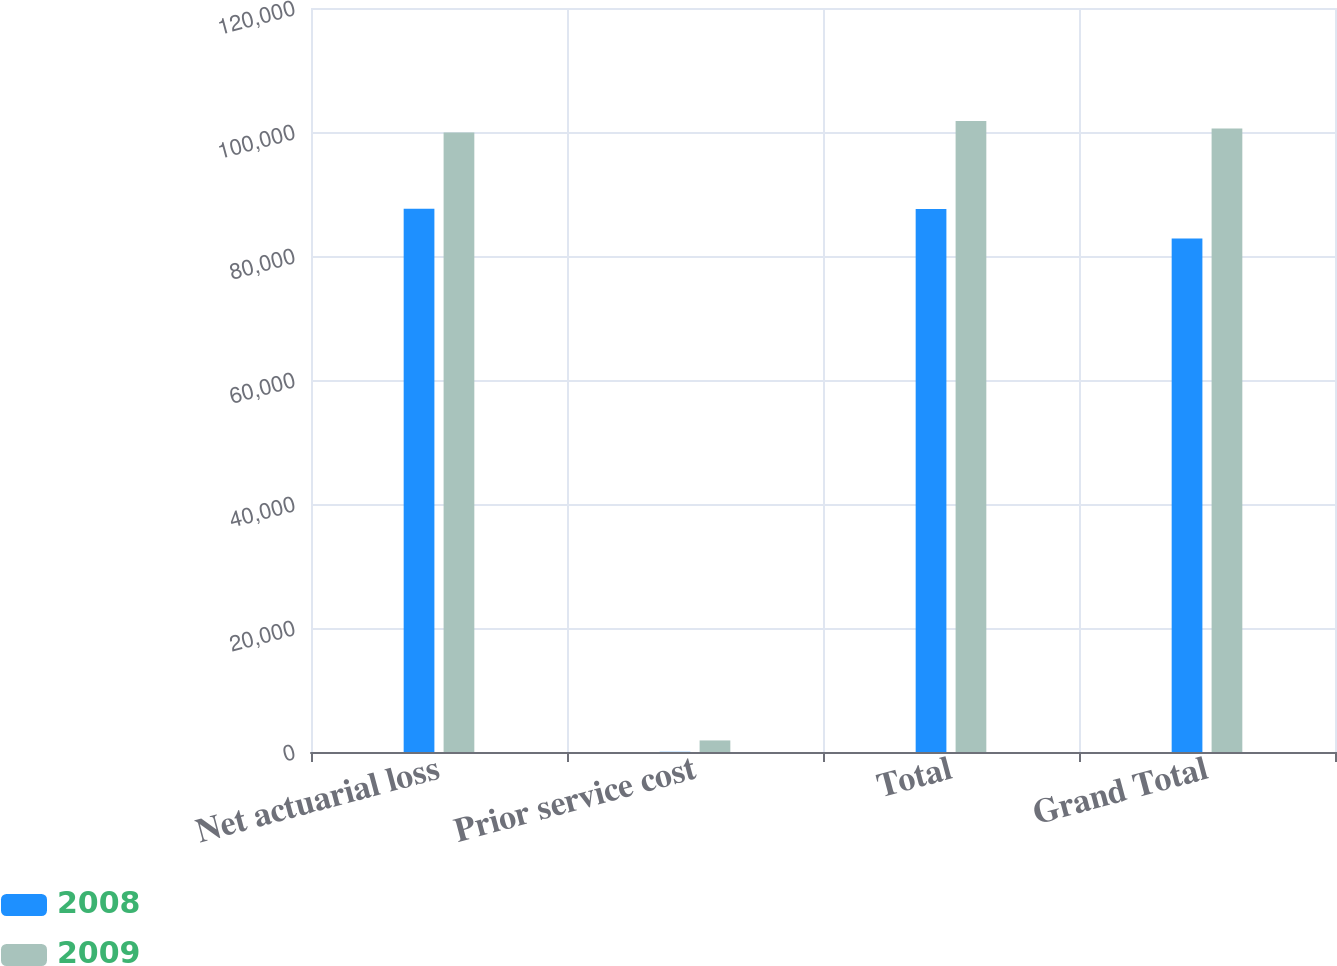Convert chart. <chart><loc_0><loc_0><loc_500><loc_500><stacked_bar_chart><ecel><fcel>Net actuarial loss<fcel>Prior service cost<fcel>Total<fcel>Grand Total<nl><fcel>2008<fcel>87613<fcel>32<fcel>87581<fcel>82826<nl><fcel>2009<fcel>99911<fcel>1865<fcel>101776<fcel>100575<nl></chart> 